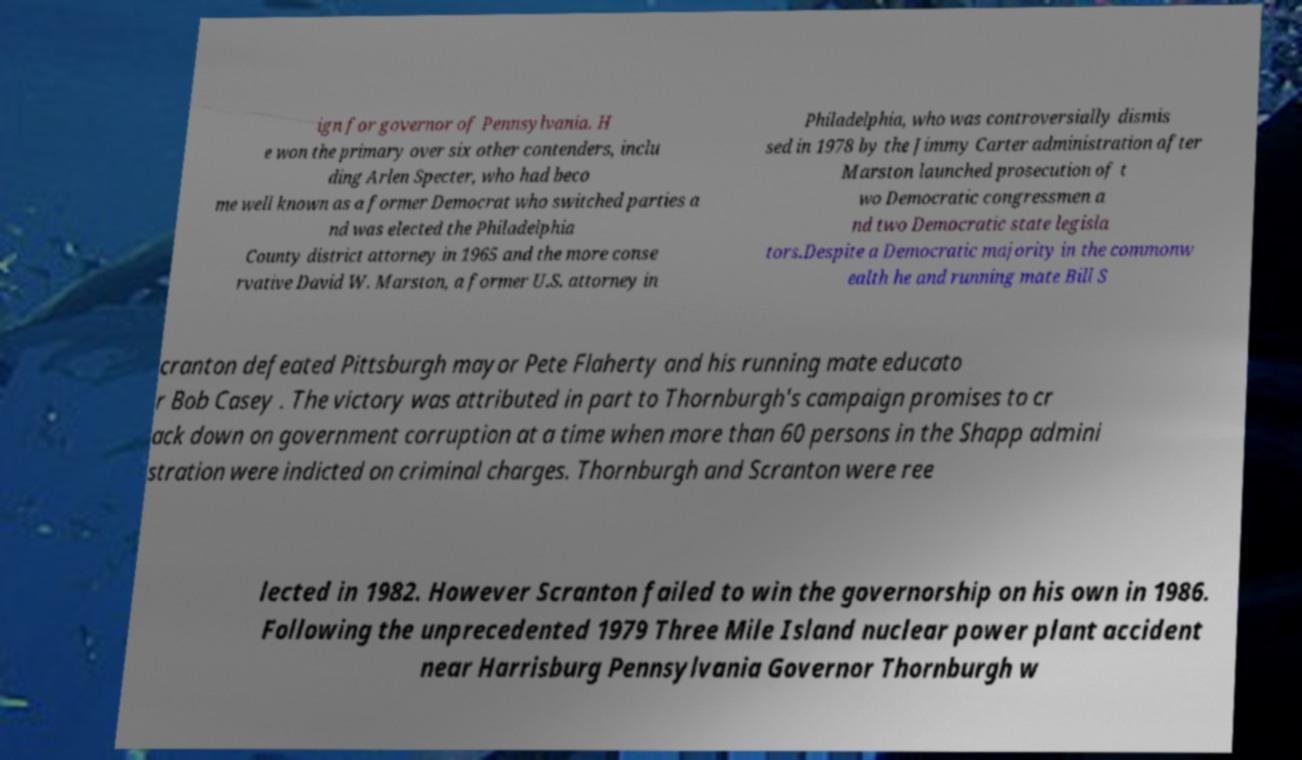Could you assist in decoding the text presented in this image and type it out clearly? ign for governor of Pennsylvania. H e won the primary over six other contenders, inclu ding Arlen Specter, who had beco me well known as a former Democrat who switched parties a nd was elected the Philadelphia County district attorney in 1965 and the more conse rvative David W. Marston, a former U.S. attorney in Philadelphia, who was controversially dismis sed in 1978 by the Jimmy Carter administration after Marston launched prosecution of t wo Democratic congressmen a nd two Democratic state legisla tors.Despite a Democratic majority in the commonw ealth he and running mate Bill S cranton defeated Pittsburgh mayor Pete Flaherty and his running mate educato r Bob Casey . The victory was attributed in part to Thornburgh's campaign promises to cr ack down on government corruption at a time when more than 60 persons in the Shapp admini stration were indicted on criminal charges. Thornburgh and Scranton were ree lected in 1982. However Scranton failed to win the governorship on his own in 1986. Following the unprecedented 1979 Three Mile Island nuclear power plant accident near Harrisburg Pennsylvania Governor Thornburgh w 